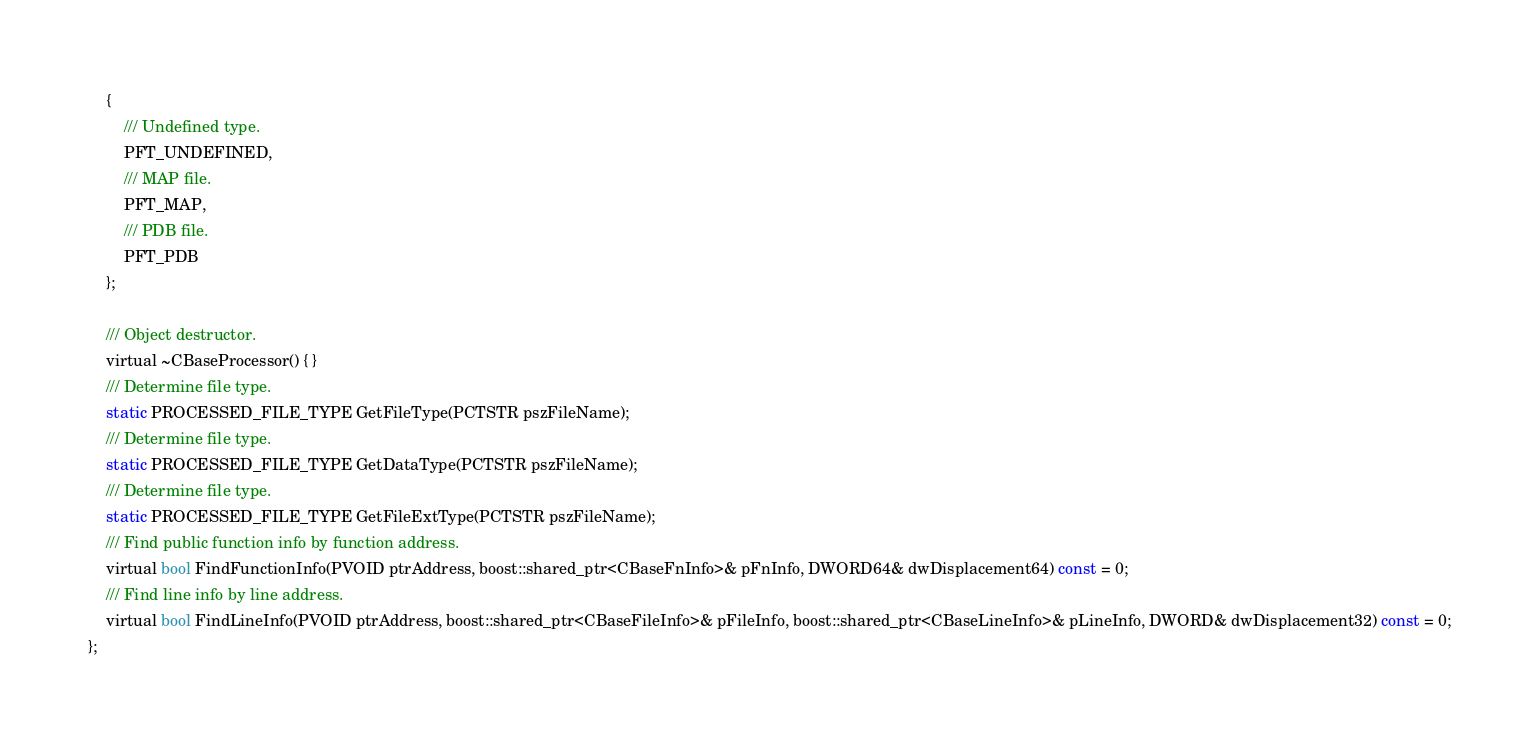Convert code to text. <code><loc_0><loc_0><loc_500><loc_500><_C_>	{
		/// Undefined type.
		PFT_UNDEFINED,
		/// MAP file.
		PFT_MAP,
		/// PDB file.
		PFT_PDB
	};

	/// Object destructor.
	virtual ~CBaseProcessor() { }
	/// Determine file type.
	static PROCESSED_FILE_TYPE GetFileType(PCTSTR pszFileName);
	/// Determine file type.
	static PROCESSED_FILE_TYPE GetDataType(PCTSTR pszFileName);
	/// Determine file type.
	static PROCESSED_FILE_TYPE GetFileExtType(PCTSTR pszFileName);
	/// Find public function info by function address.
	virtual bool FindFunctionInfo(PVOID ptrAddress, boost::shared_ptr<CBaseFnInfo>& pFnInfo, DWORD64& dwDisplacement64) const = 0;
	/// Find line info by line address.
	virtual bool FindLineInfo(PVOID ptrAddress, boost::shared_ptr<CBaseFileInfo>& pFileInfo, boost::shared_ptr<CBaseLineInfo>& pLineInfo, DWORD& dwDisplacement32) const = 0;
};
</code> 